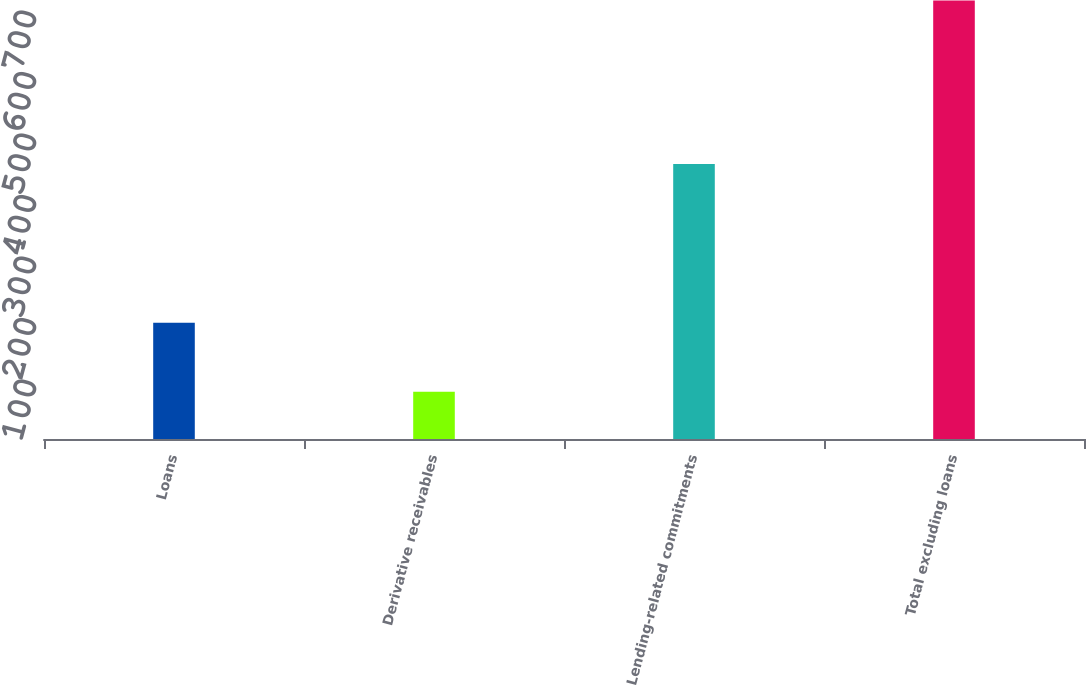<chart> <loc_0><loc_0><loc_500><loc_500><bar_chart><fcel>Loans<fcel>Derivative receivables<fcel>Lending-related commitments<fcel>Total excluding loans<nl><fcel>189<fcel>77<fcel>447<fcel>713<nl></chart> 